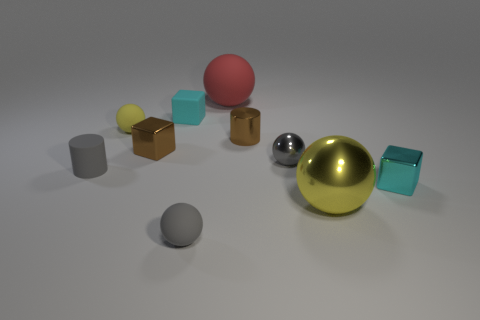Subtract all big metallic spheres. How many spheres are left? 4 Subtract all red balls. How many balls are left? 4 Subtract all cyan balls. Subtract all blue blocks. How many balls are left? 5 Subtract all blocks. How many objects are left? 7 Add 5 big red spheres. How many big red spheres are left? 6 Add 7 large things. How many large things exist? 9 Subtract 0 brown spheres. How many objects are left? 10 Subtract all tiny red rubber cubes. Subtract all brown blocks. How many objects are left? 9 